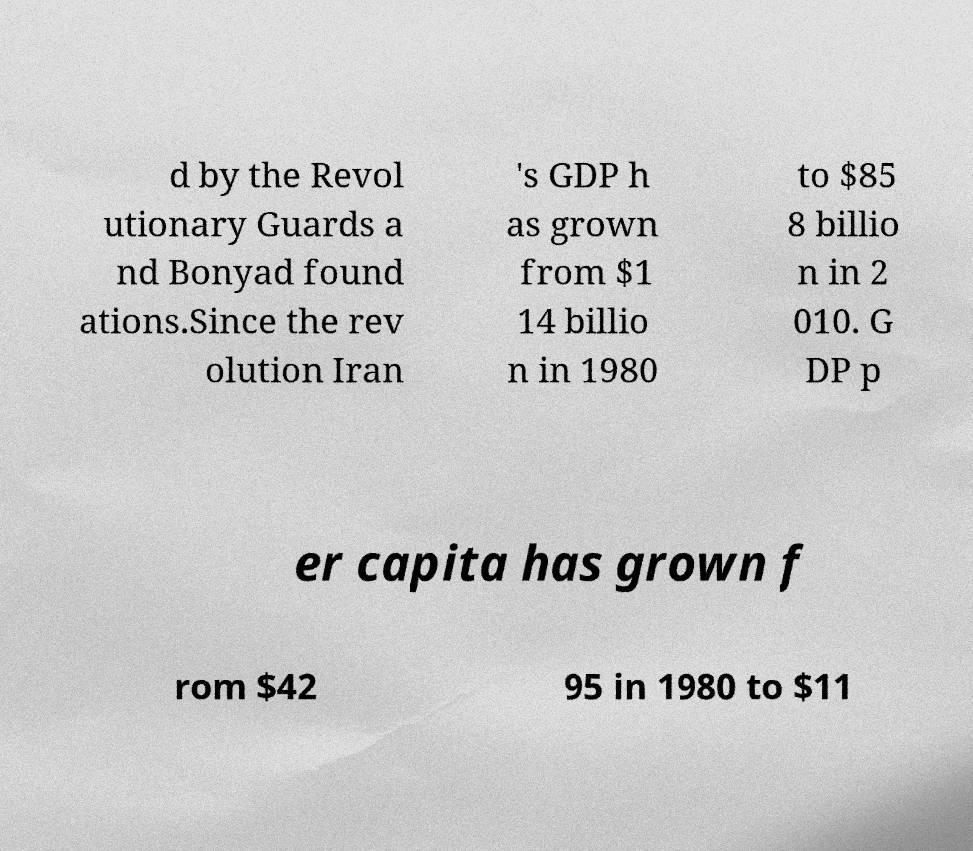I need the written content from this picture converted into text. Can you do that? d by the Revol utionary Guards a nd Bonyad found ations.Since the rev olution Iran 's GDP h as grown from $1 14 billio n in 1980 to $85 8 billio n in 2 010. G DP p er capita has grown f rom $42 95 in 1980 to $11 